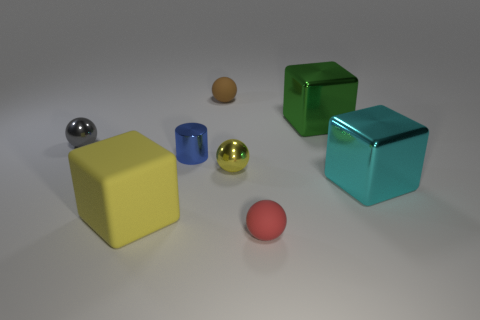Add 1 small yellow objects. How many objects exist? 9 Subtract all cubes. How many objects are left? 5 Subtract 0 brown cylinders. How many objects are left? 8 Subtract all large blue things. Subtract all matte balls. How many objects are left? 6 Add 6 large green shiny cubes. How many large green shiny cubes are left? 7 Add 4 rubber spheres. How many rubber spheres exist? 6 